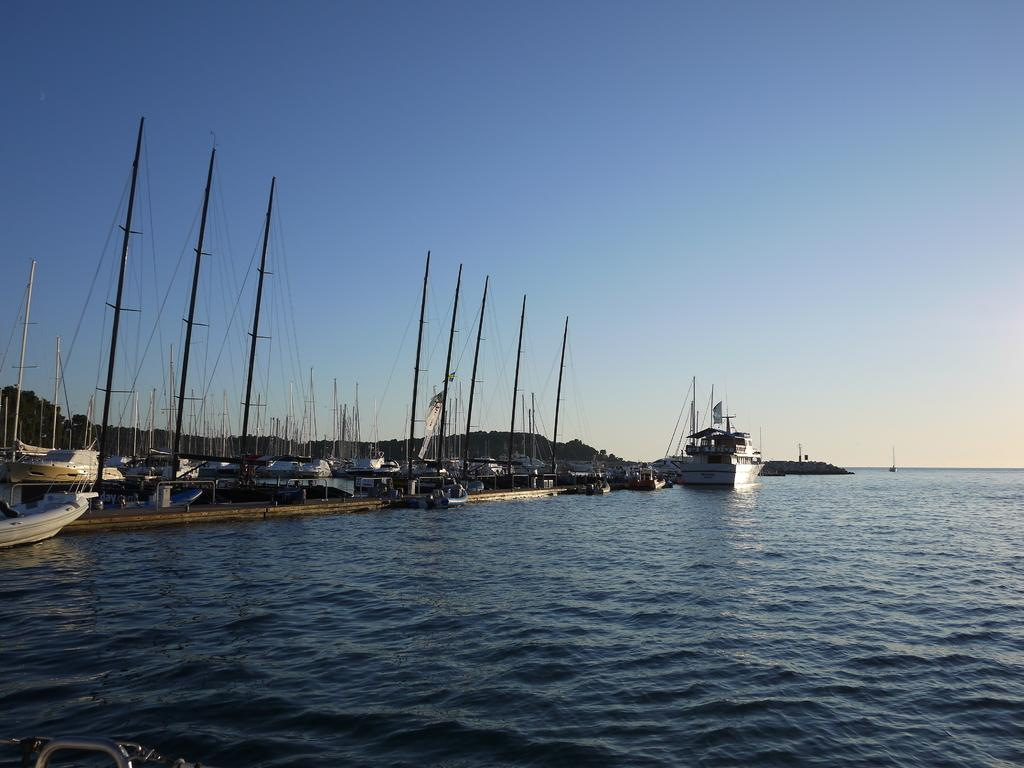What is the main subject of the image? The main subject of the image is a group of boats. Where are the boats located? The boats are on the water. What can be seen in the background of the image? There are trees and other objects in the background of the image, as well as the sky. Can you tell me which governor is in charge of the boats in the image? There is no governor present in the image, as it features a group of boats on the water with no indication of any governing authority. 